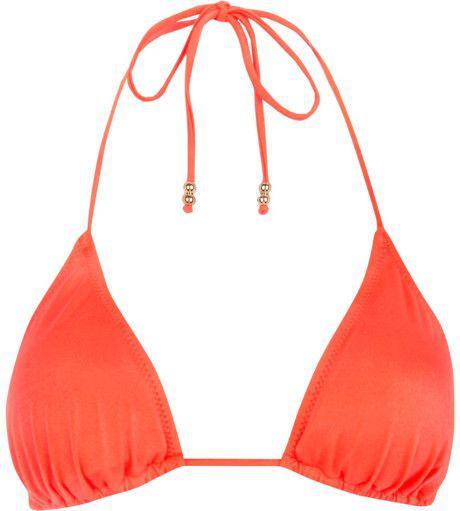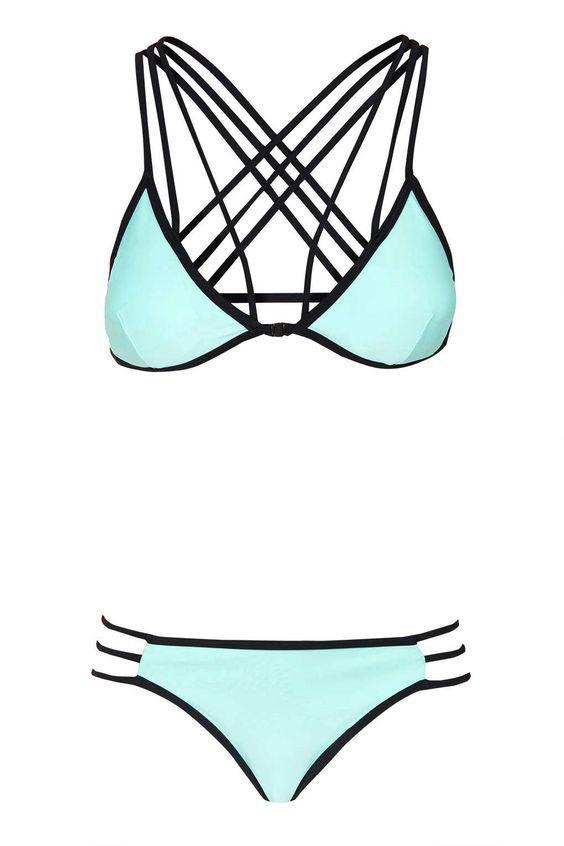The first image is the image on the left, the second image is the image on the right. For the images shown, is this caption "The images show only brightly colored bikini tops that tie halter-style." true? Answer yes or no. No. 